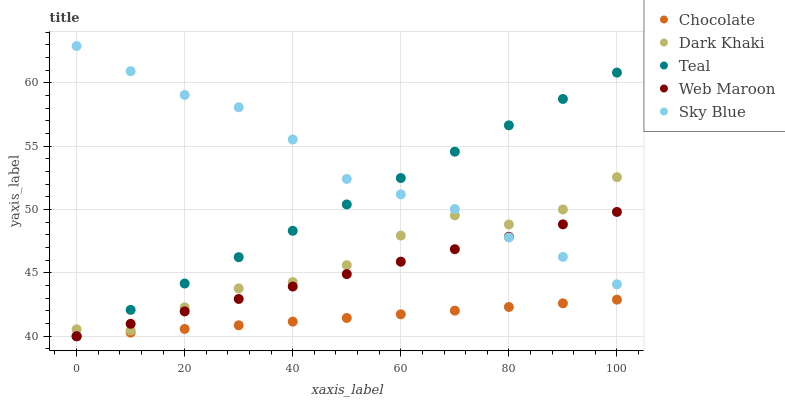Does Chocolate have the minimum area under the curve?
Answer yes or no. Yes. Does Sky Blue have the maximum area under the curve?
Answer yes or no. Yes. Does Web Maroon have the minimum area under the curve?
Answer yes or no. No. Does Web Maroon have the maximum area under the curve?
Answer yes or no. No. Is Teal the smoothest?
Answer yes or no. Yes. Is Dark Khaki the roughest?
Answer yes or no. Yes. Is Sky Blue the smoothest?
Answer yes or no. No. Is Sky Blue the roughest?
Answer yes or no. No. Does Web Maroon have the lowest value?
Answer yes or no. Yes. Does Sky Blue have the lowest value?
Answer yes or no. No. Does Sky Blue have the highest value?
Answer yes or no. Yes. Does Web Maroon have the highest value?
Answer yes or no. No. Is Chocolate less than Sky Blue?
Answer yes or no. Yes. Is Sky Blue greater than Chocolate?
Answer yes or no. Yes. Does Web Maroon intersect Sky Blue?
Answer yes or no. Yes. Is Web Maroon less than Sky Blue?
Answer yes or no. No. Is Web Maroon greater than Sky Blue?
Answer yes or no. No. Does Chocolate intersect Sky Blue?
Answer yes or no. No. 